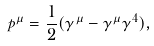<formula> <loc_0><loc_0><loc_500><loc_500>p ^ { \mu } = \frac { 1 } { 2 } ( \gamma ^ { \mu } - \gamma ^ { \mu } \gamma ^ { 4 } ) ,</formula> 